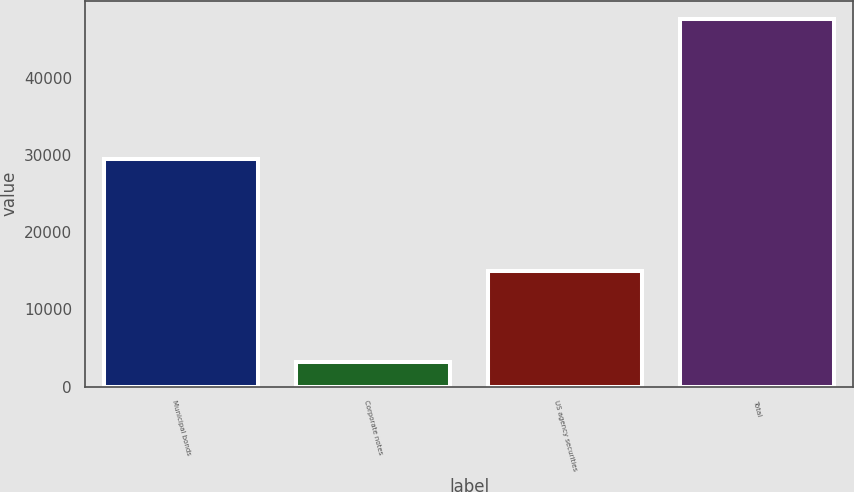Convert chart. <chart><loc_0><loc_0><loc_500><loc_500><bar_chart><fcel>Municipal bonds<fcel>Corporate notes<fcel>US agency securities<fcel>Total<nl><fcel>29484<fcel>3151<fcel>14964<fcel>47599<nl></chart> 